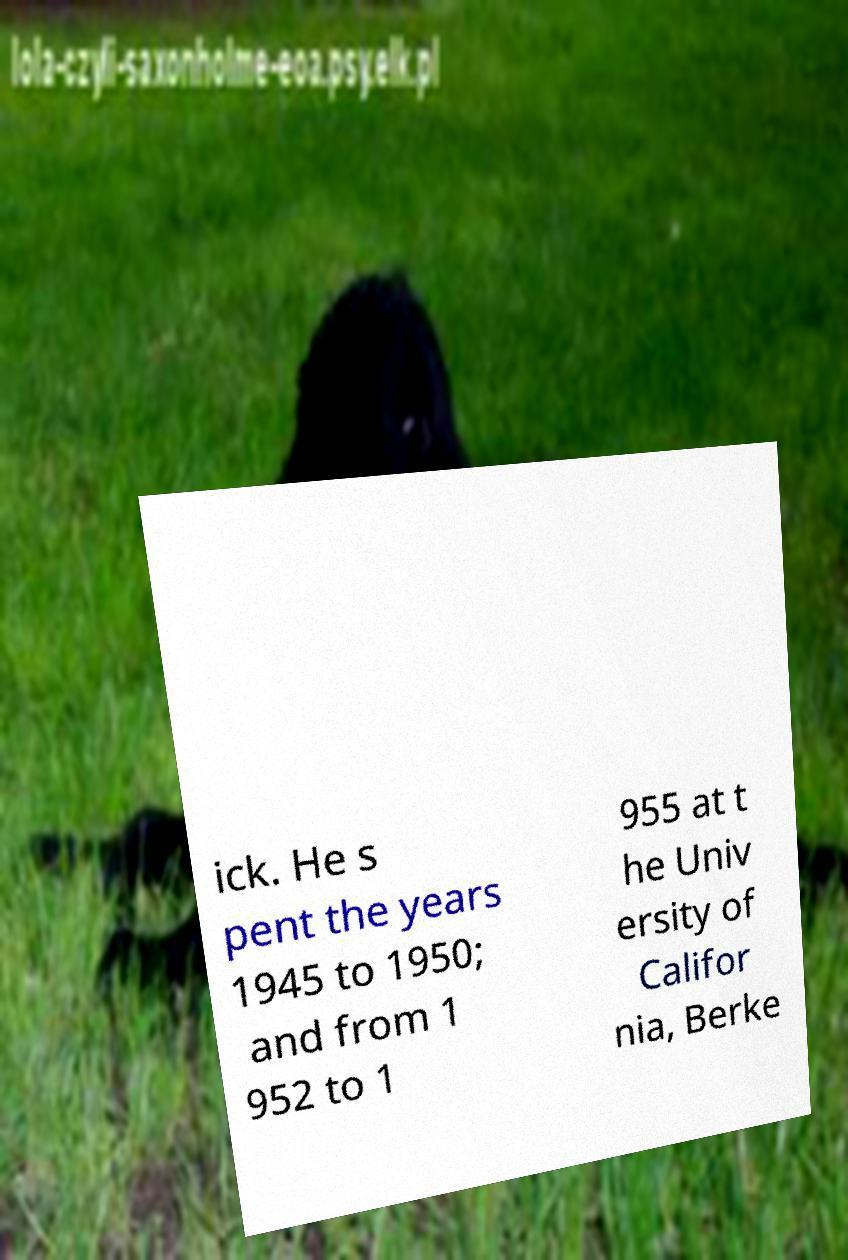What messages or text are displayed in this image? I need them in a readable, typed format. ick. He s pent the years 1945 to 1950; and from 1 952 to 1 955 at t he Univ ersity of Califor nia, Berke 